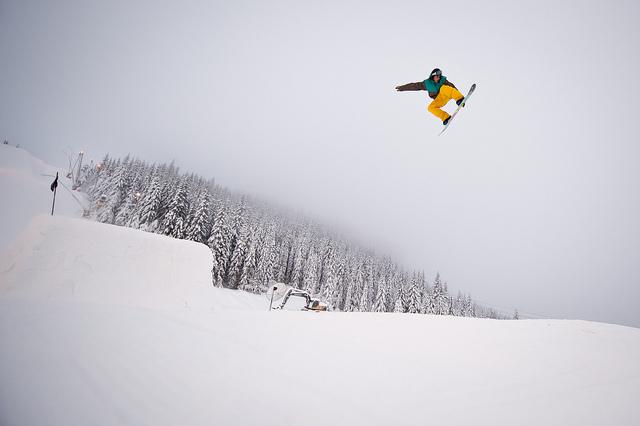Is there snow on the ground?
Give a very brief answer. Yes. Are there a lot of spectators?
Quick response, please. No. Is this man flying through the air?
Quick response, please. Yes. Is this person ice fishing?
Answer briefly. No. What is this man on?
Concise answer only. Snowboard. 